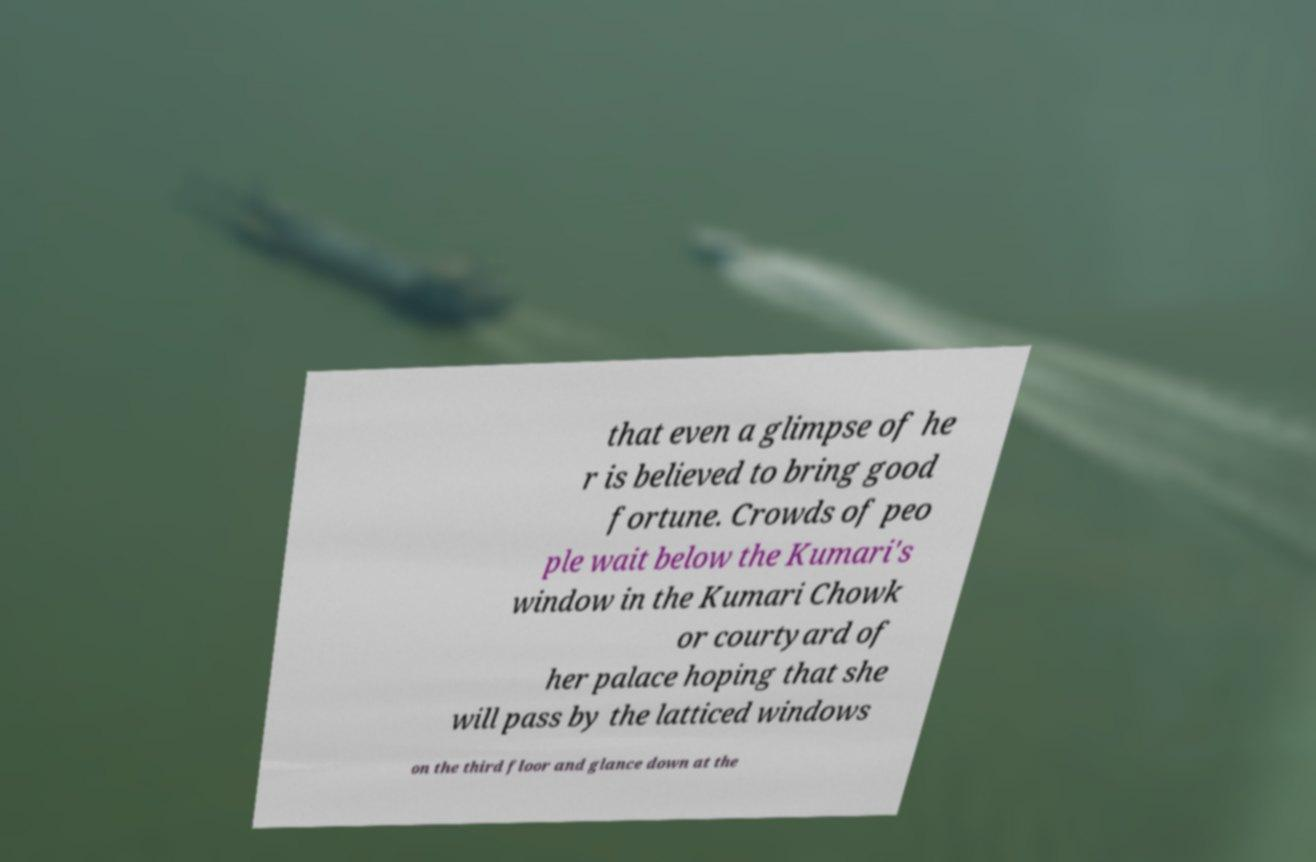Please read and relay the text visible in this image. What does it say? that even a glimpse of he r is believed to bring good fortune. Crowds of peo ple wait below the Kumari's window in the Kumari Chowk or courtyard of her palace hoping that she will pass by the latticed windows on the third floor and glance down at the 